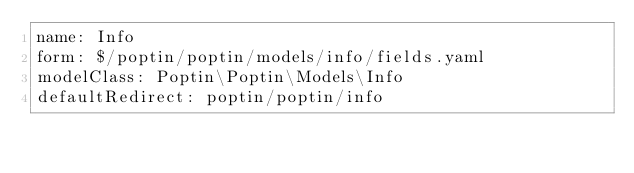<code> <loc_0><loc_0><loc_500><loc_500><_YAML_>name: Info
form: $/poptin/poptin/models/info/fields.yaml
modelClass: Poptin\Poptin\Models\Info
defaultRedirect: poptin/poptin/info
</code> 